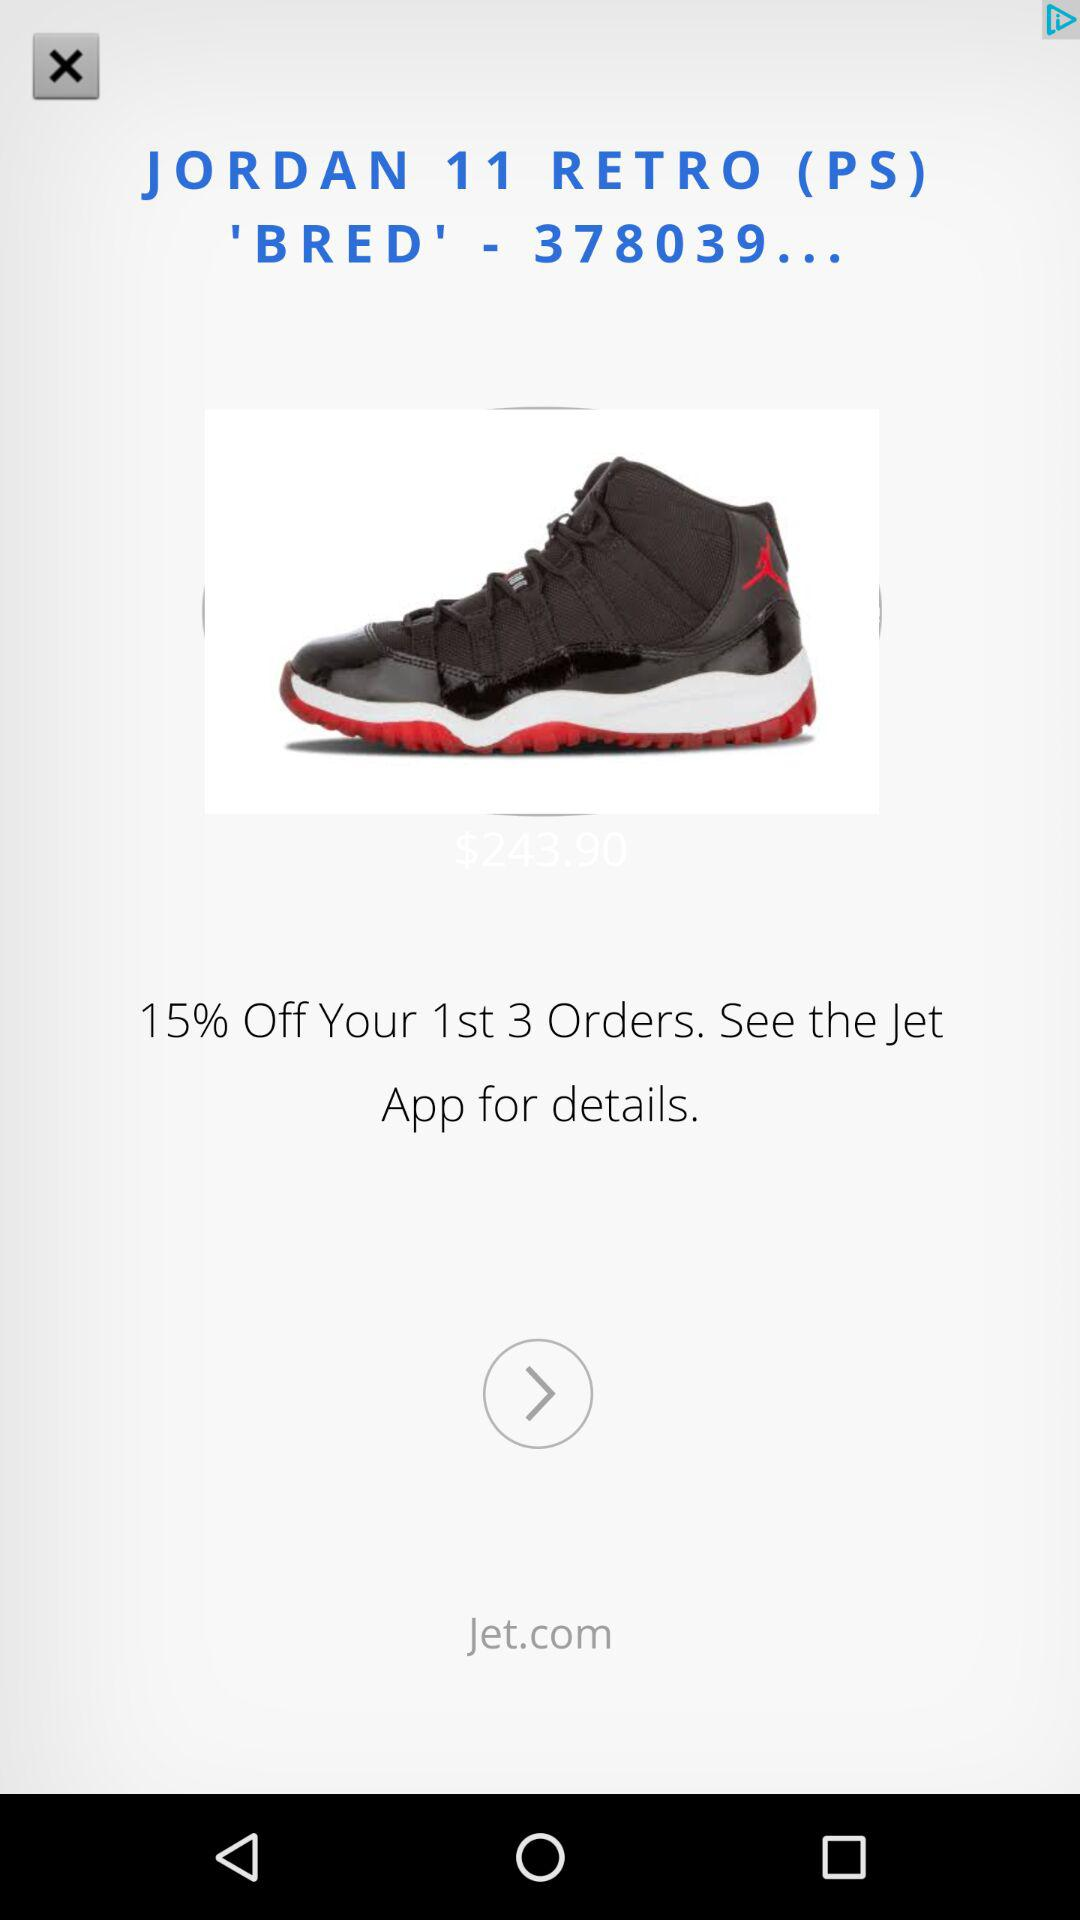How much is the discount on the Jordan 11 Retro (PS) 'Bred'?
Answer the question using a single word or phrase. 15% 